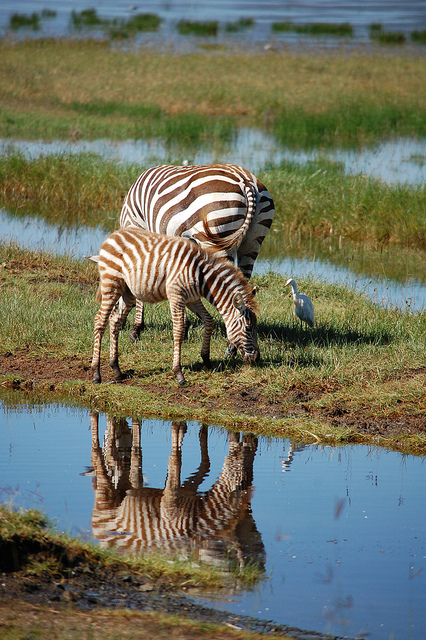<image>What kind of bird is that? I don't know what kind of bird that is. It can be stork, pelican, tern, swan, heron, seagull or duck. What kind of bird is that? I am not sure what kind of bird is that. But it can be seen stork, pelican, tern, swan, heron, seagull or duck. 